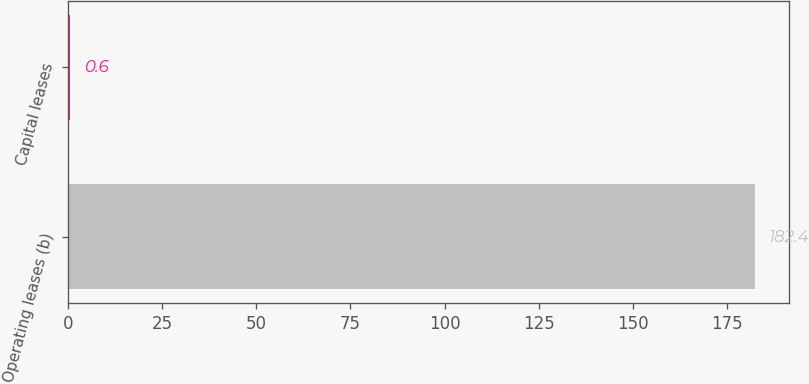Convert chart. <chart><loc_0><loc_0><loc_500><loc_500><bar_chart><fcel>Operating leases (b)<fcel>Capital leases<nl><fcel>182.4<fcel>0.6<nl></chart> 